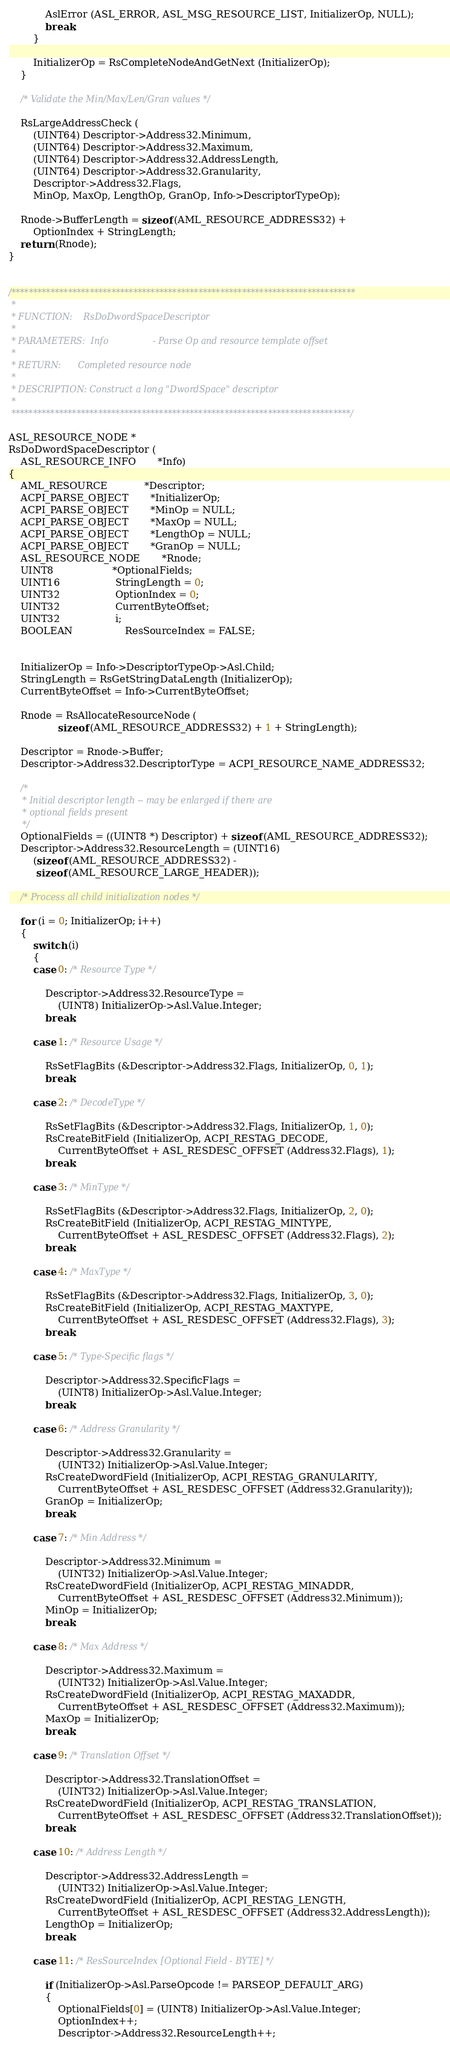Convert code to text. <code><loc_0><loc_0><loc_500><loc_500><_C_>
            AslError (ASL_ERROR, ASL_MSG_RESOURCE_LIST, InitializerOp, NULL);
            break;
        }

        InitializerOp = RsCompleteNodeAndGetNext (InitializerOp);
    }

    /* Validate the Min/Max/Len/Gran values */

    RsLargeAddressCheck (
        (UINT64) Descriptor->Address32.Minimum,
        (UINT64) Descriptor->Address32.Maximum,
        (UINT64) Descriptor->Address32.AddressLength,
        (UINT64) Descriptor->Address32.Granularity,
        Descriptor->Address32.Flags,
        MinOp, MaxOp, LengthOp, GranOp, Info->DescriptorTypeOp);

    Rnode->BufferLength = sizeof (AML_RESOURCE_ADDRESS32) +
        OptionIndex + StringLength;
    return (Rnode);
}


/*******************************************************************************
 *
 * FUNCTION:    RsDoDwordSpaceDescriptor
 *
 * PARAMETERS:  Info                - Parse Op and resource template offset
 *
 * RETURN:      Completed resource node
 *
 * DESCRIPTION: Construct a long "DwordSpace" descriptor
 *
 ******************************************************************************/

ASL_RESOURCE_NODE *
RsDoDwordSpaceDescriptor (
    ASL_RESOURCE_INFO       *Info)
{
    AML_RESOURCE            *Descriptor;
    ACPI_PARSE_OBJECT       *InitializerOp;
    ACPI_PARSE_OBJECT       *MinOp = NULL;
    ACPI_PARSE_OBJECT       *MaxOp = NULL;
    ACPI_PARSE_OBJECT       *LengthOp = NULL;
    ACPI_PARSE_OBJECT       *GranOp = NULL;
    ASL_RESOURCE_NODE       *Rnode;
    UINT8                   *OptionalFields;
    UINT16                  StringLength = 0;
    UINT32                  OptionIndex = 0;
    UINT32                  CurrentByteOffset;
    UINT32                  i;
    BOOLEAN                 ResSourceIndex = FALSE;


    InitializerOp = Info->DescriptorTypeOp->Asl.Child;
    StringLength = RsGetStringDataLength (InitializerOp);
    CurrentByteOffset = Info->CurrentByteOffset;

    Rnode = RsAllocateResourceNode (
                sizeof (AML_RESOURCE_ADDRESS32) + 1 + StringLength);

    Descriptor = Rnode->Buffer;
    Descriptor->Address32.DescriptorType = ACPI_RESOURCE_NAME_ADDRESS32;

    /*
     * Initial descriptor length -- may be enlarged if there are
     * optional fields present
     */
    OptionalFields = ((UINT8 *) Descriptor) + sizeof (AML_RESOURCE_ADDRESS32);
    Descriptor->Address32.ResourceLength = (UINT16)
        (sizeof (AML_RESOURCE_ADDRESS32) -
         sizeof (AML_RESOURCE_LARGE_HEADER));

    /* Process all child initialization nodes */

    for (i = 0; InitializerOp; i++)
    {
        switch (i)
        {
        case 0: /* Resource Type */

            Descriptor->Address32.ResourceType =
                (UINT8) InitializerOp->Asl.Value.Integer;
            break;

        case 1: /* Resource Usage */

            RsSetFlagBits (&Descriptor->Address32.Flags, InitializerOp, 0, 1);
            break;

        case 2: /* DecodeType */

            RsSetFlagBits (&Descriptor->Address32.Flags, InitializerOp, 1, 0);
            RsCreateBitField (InitializerOp, ACPI_RESTAG_DECODE,
                CurrentByteOffset + ASL_RESDESC_OFFSET (Address32.Flags), 1);
            break;

        case 3: /* MinType */

            RsSetFlagBits (&Descriptor->Address32.Flags, InitializerOp, 2, 0);
            RsCreateBitField (InitializerOp, ACPI_RESTAG_MINTYPE,
                CurrentByteOffset + ASL_RESDESC_OFFSET (Address32.Flags), 2);
            break;

        case 4: /* MaxType */

            RsSetFlagBits (&Descriptor->Address32.Flags, InitializerOp, 3, 0);
            RsCreateBitField (InitializerOp, ACPI_RESTAG_MAXTYPE,
                CurrentByteOffset + ASL_RESDESC_OFFSET (Address32.Flags), 3);
            break;

        case 5: /* Type-Specific flags */

            Descriptor->Address32.SpecificFlags =
                (UINT8) InitializerOp->Asl.Value.Integer;
            break;

        case 6: /* Address Granularity */

            Descriptor->Address32.Granularity =
                (UINT32) InitializerOp->Asl.Value.Integer;
            RsCreateDwordField (InitializerOp, ACPI_RESTAG_GRANULARITY,
                CurrentByteOffset + ASL_RESDESC_OFFSET (Address32.Granularity));
            GranOp = InitializerOp;
            break;

        case 7: /* Min Address */

            Descriptor->Address32.Minimum =
                (UINT32) InitializerOp->Asl.Value.Integer;
            RsCreateDwordField (InitializerOp, ACPI_RESTAG_MINADDR,
                CurrentByteOffset + ASL_RESDESC_OFFSET (Address32.Minimum));
            MinOp = InitializerOp;
            break;

        case 8: /* Max Address */

            Descriptor->Address32.Maximum =
                (UINT32) InitializerOp->Asl.Value.Integer;
            RsCreateDwordField (InitializerOp, ACPI_RESTAG_MAXADDR,
                CurrentByteOffset + ASL_RESDESC_OFFSET (Address32.Maximum));
            MaxOp = InitializerOp;
            break;

        case 9: /* Translation Offset */

            Descriptor->Address32.TranslationOffset =
                (UINT32) InitializerOp->Asl.Value.Integer;
            RsCreateDwordField (InitializerOp, ACPI_RESTAG_TRANSLATION,
                CurrentByteOffset + ASL_RESDESC_OFFSET (Address32.TranslationOffset));
            break;

        case 10: /* Address Length */

            Descriptor->Address32.AddressLength =
                (UINT32) InitializerOp->Asl.Value.Integer;
            RsCreateDwordField (InitializerOp, ACPI_RESTAG_LENGTH,
                CurrentByteOffset + ASL_RESDESC_OFFSET (Address32.AddressLength));
            LengthOp = InitializerOp;
            break;

        case 11: /* ResSourceIndex [Optional Field - BYTE] */

            if (InitializerOp->Asl.ParseOpcode != PARSEOP_DEFAULT_ARG)
            {
                OptionalFields[0] = (UINT8) InitializerOp->Asl.Value.Integer;
                OptionIndex++;
                Descriptor->Address32.ResourceLength++;</code> 